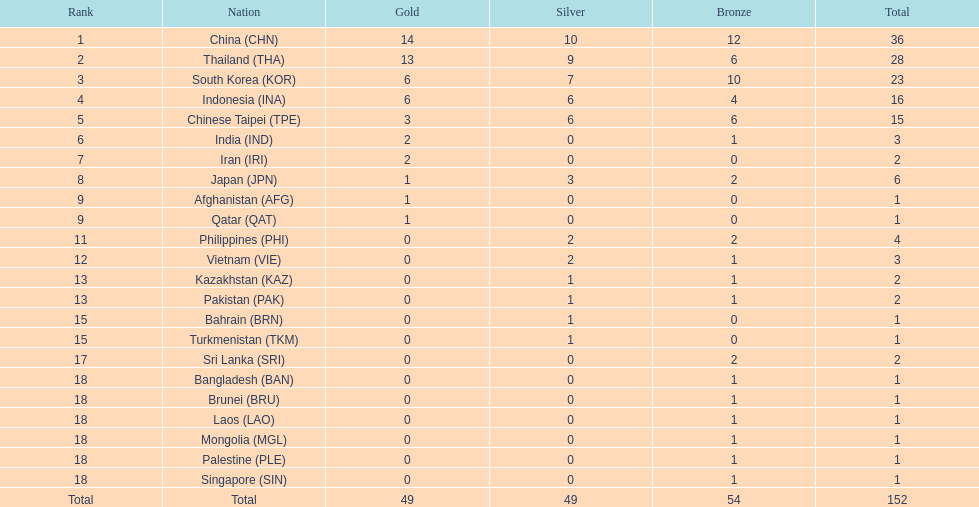How many nations won no silver medals at all? 11. 